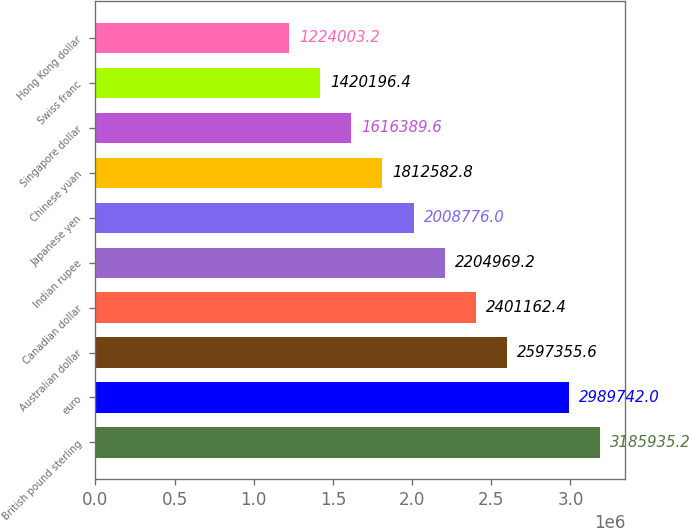Convert chart. <chart><loc_0><loc_0><loc_500><loc_500><bar_chart><fcel>British pound sterling<fcel>euro<fcel>Australian dollar<fcel>Canadian dollar<fcel>Indian rupee<fcel>Japanese yen<fcel>Chinese yuan<fcel>Singapore dollar<fcel>Swiss franc<fcel>Hong Kong dollar<nl><fcel>3.18594e+06<fcel>2.98974e+06<fcel>2.59736e+06<fcel>2.40116e+06<fcel>2.20497e+06<fcel>2.00878e+06<fcel>1.81258e+06<fcel>1.61639e+06<fcel>1.4202e+06<fcel>1.224e+06<nl></chart> 